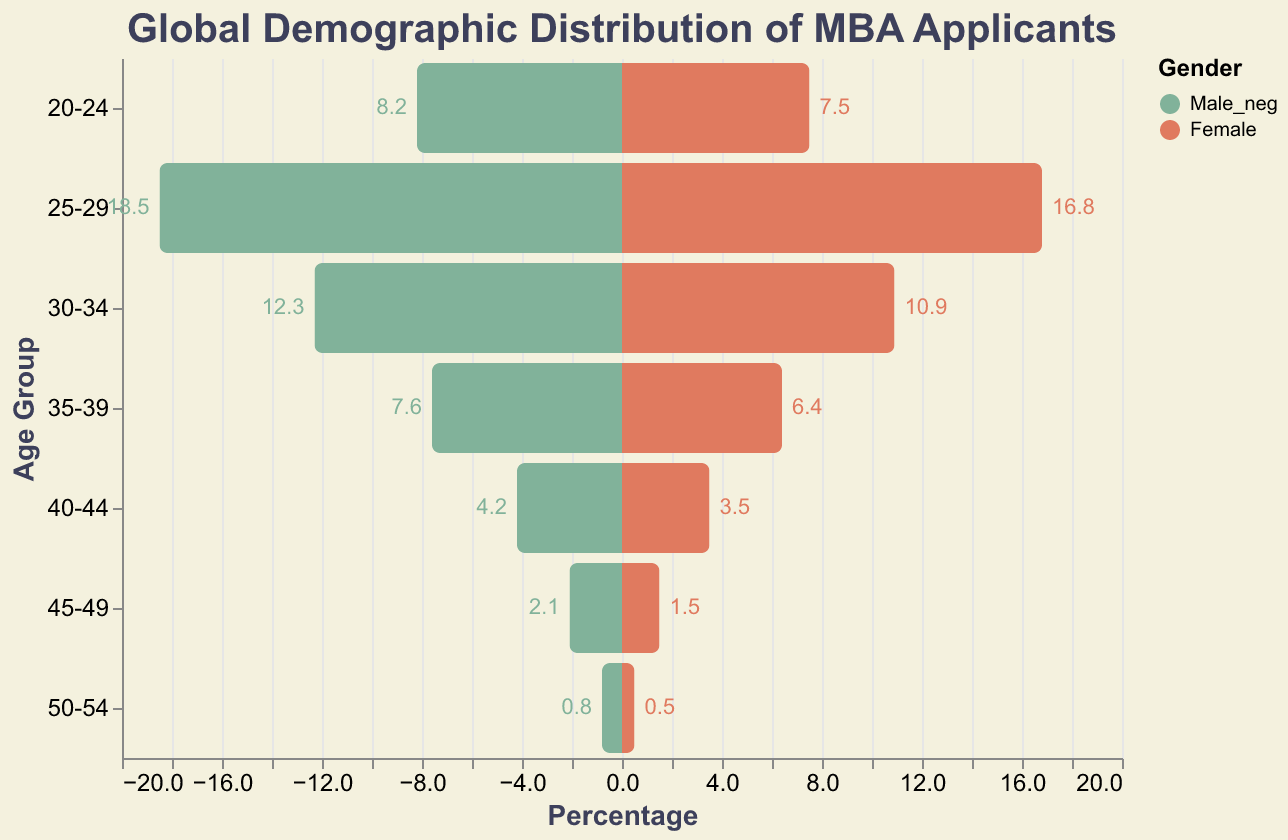What is the title of the population pyramid plot? The title of the population pyramid plot is provided at the top, reading "Global Demographic Distribution of MBA Applicants."
Answer: Global Demographic Distribution of MBA Applicants How many age groups are represented in the population pyramid? The age groups can be directly counted from the figure; they include "20-24," "25-29," "30-34," "35-39," "40-44," "45-49," and "50-54." So, there are 7 age groups.
Answer: 7 Which age group has the highest percentage of female MBA applicants? By observing the bars corresponding to females across different age groups, the "25-29" age group has the highest percentage, which is 16.8%.
Answer: 25-29 What is the main color used to represent males in the population pyramid plot? Males are represented by bars colored in a shade of green.
Answer: Green What is the age group with the smallest gap between male and female percentages? To determine this, compare the differences between male and female percentages across age groups. The "50-54" age group has the smallest gap, with males at 0.8% and females at 0.5%. The difference is 0.3%.
Answer: 50-54 What percentage of MBA applicants are males in the 30-34 age group? By reading the corresponding bars for males in the 30-34 age group in the pyramid, we see that it is 12.3%.
Answer: 12.3% What is the average percentage of female applicants in the age groups 25-29 and 30-34? Sum up the percentages of females in these two age groups (16.8% and 10.9%) and divide by 2. The average is (16.8 + 10.9)/2 = 13.85%.
Answer: 13.85% What is the percentage difference between males and females in the 40-44 age group? Subtract the female percentage from the male percentage for the 40-44 age group: 4.2% - 3.5% = 0.7% difference.
Answer: 0.7% In which age group is the female percentage roughly half the male percentage? By evaluating the ratios of female to male percentages, the "45-49" age group stands out where 1.5% is around half of 2.1%.
Answer: 45-49 What is the sum of male and female applicant percentages in the 25-29 age group? Adding the male and female percentages for the 25-29 age group: 18.5% + 16.8% = 35.3%.
Answer: 35.3% 